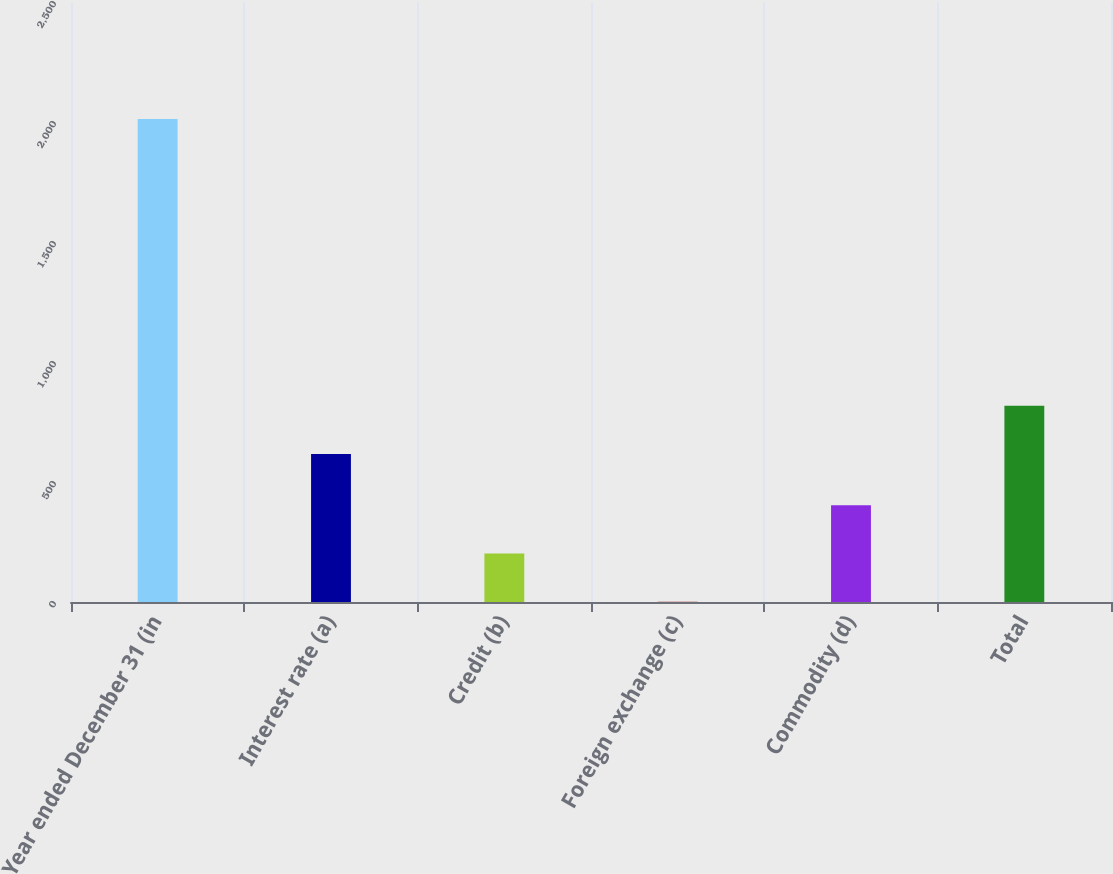Convert chart. <chart><loc_0><loc_0><loc_500><loc_500><bar_chart><fcel>Year ended December 31 (in<fcel>Interest rate (a)<fcel>Credit (b)<fcel>Foreign exchange (c)<fcel>Commodity (d)<fcel>Total<nl><fcel>2013<fcel>617<fcel>202.2<fcel>1<fcel>403.4<fcel>818.2<nl></chart> 